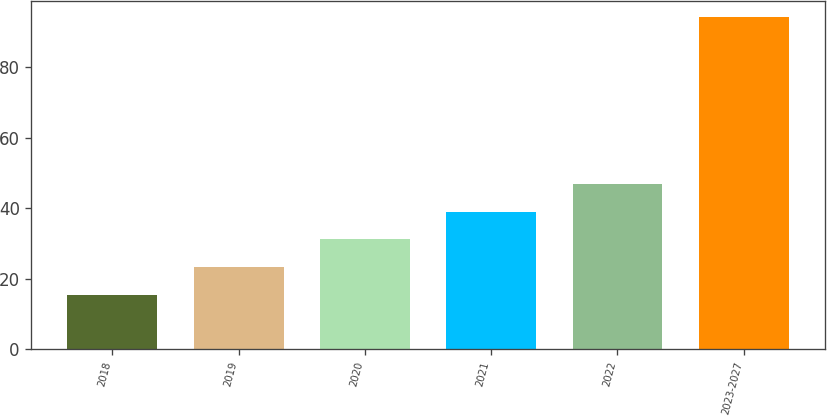Convert chart. <chart><loc_0><loc_0><loc_500><loc_500><bar_chart><fcel>2018<fcel>2019<fcel>2020<fcel>2021<fcel>2022<fcel>2023-2027<nl><fcel>15.3<fcel>23.2<fcel>31.1<fcel>39<fcel>46.9<fcel>94.3<nl></chart> 